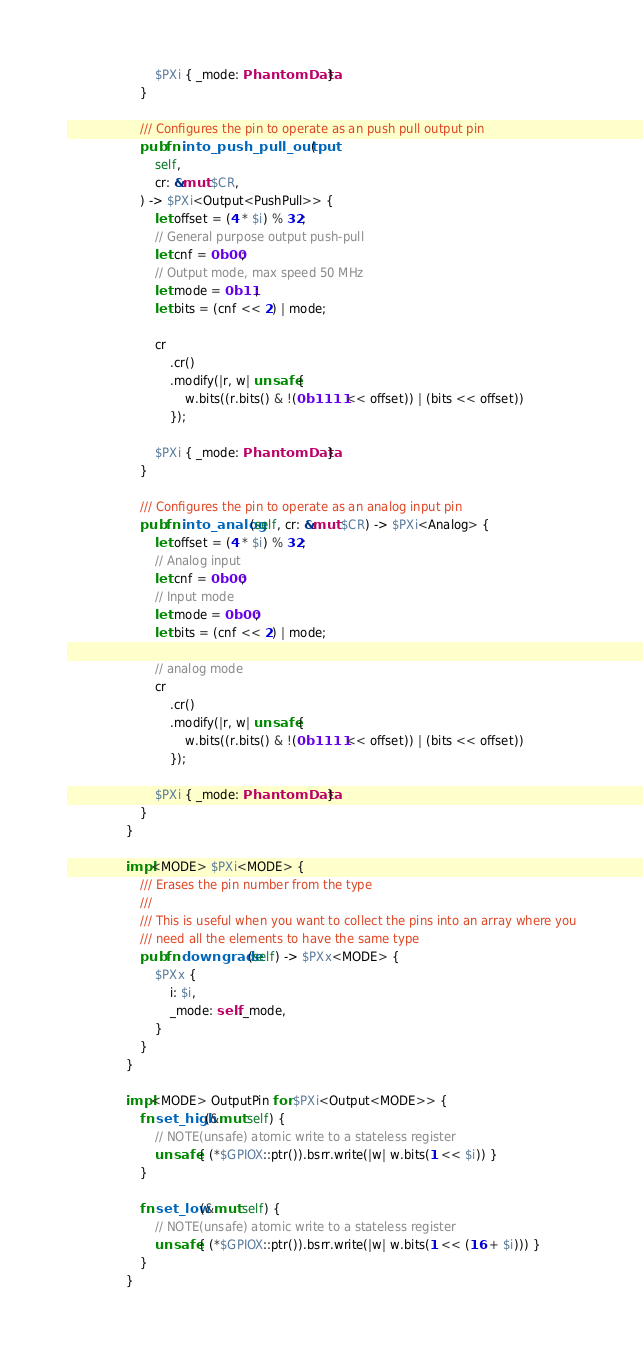<code> <loc_0><loc_0><loc_500><loc_500><_Rust_>
                        $PXi { _mode: PhantomData }
                    }

                    /// Configures the pin to operate as an push pull output pin
                    pub fn into_push_pull_output(
                        self,
                        cr: &mut $CR,
                    ) -> $PXi<Output<PushPull>> {
                        let offset = (4 * $i) % 32;
                        // General purpose output push-pull
                        let cnf = 0b00;
                        // Output mode, max speed 50 MHz
                        let mode = 0b11;
                        let bits = (cnf << 2) | mode;

                        cr
                            .cr()
                            .modify(|r, w| unsafe {
                                w.bits((r.bits() & !(0b1111 << offset)) | (bits << offset))
                            });

                        $PXi { _mode: PhantomData }
                    }
                    
                    /// Configures the pin to operate as an analog input pin
                    pub fn into_analog(self, cr: &mut $CR) -> $PXi<Analog> {
                        let offset = (4 * $i) % 32;
                        // Analog input
                        let cnf = 0b00;
                        // Input mode
                        let mode = 0b00;
                        let bits = (cnf << 2) | mode;

                        // analog mode
                        cr
                            .cr()
                            .modify(|r, w| unsafe {
                                w.bits((r.bits() & !(0b1111 << offset)) | (bits << offset))
                            });

                        $PXi { _mode: PhantomData }
                    }
                }

                impl<MODE> $PXi<MODE> {
                    /// Erases the pin number from the type
                    ///
                    /// This is useful when you want to collect the pins into an array where you
                    /// need all the elements to have the same type
                    pub fn downgrade(self) -> $PXx<MODE> {
                        $PXx {
                            i: $i,
                            _mode: self._mode,
                        }
                    }
                }

                impl<MODE> OutputPin for $PXi<Output<MODE>> {
                    fn set_high(&mut self) {
                        // NOTE(unsafe) atomic write to a stateless register
                        unsafe { (*$GPIOX::ptr()).bsrr.write(|w| w.bits(1 << $i)) }
                    }

                    fn set_low(&mut self) {
                        // NOTE(unsafe) atomic write to a stateless register
                        unsafe { (*$GPIOX::ptr()).bsrr.write(|w| w.bits(1 << (16 + $i))) }
                    }
                }
</code> 